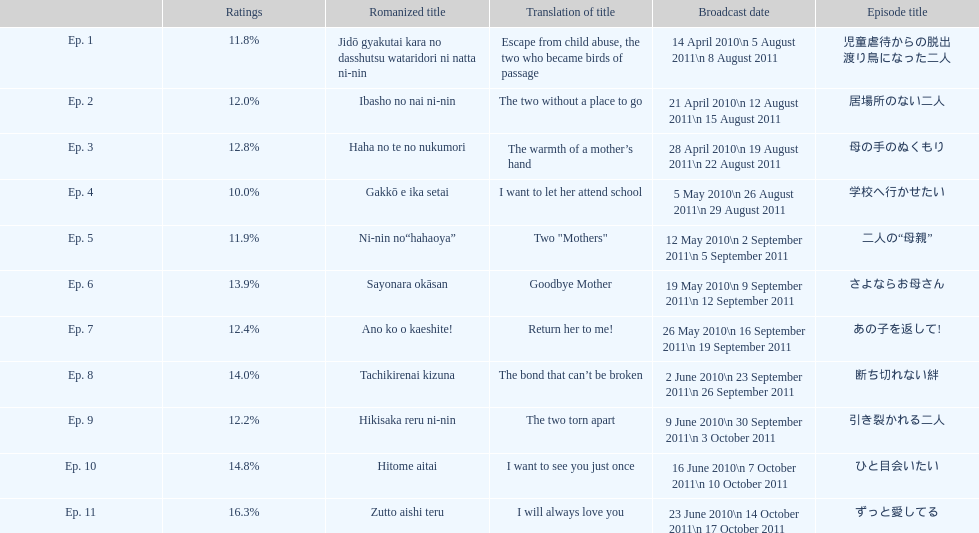How many episodes had a consecutive rating over 11%? 7. 